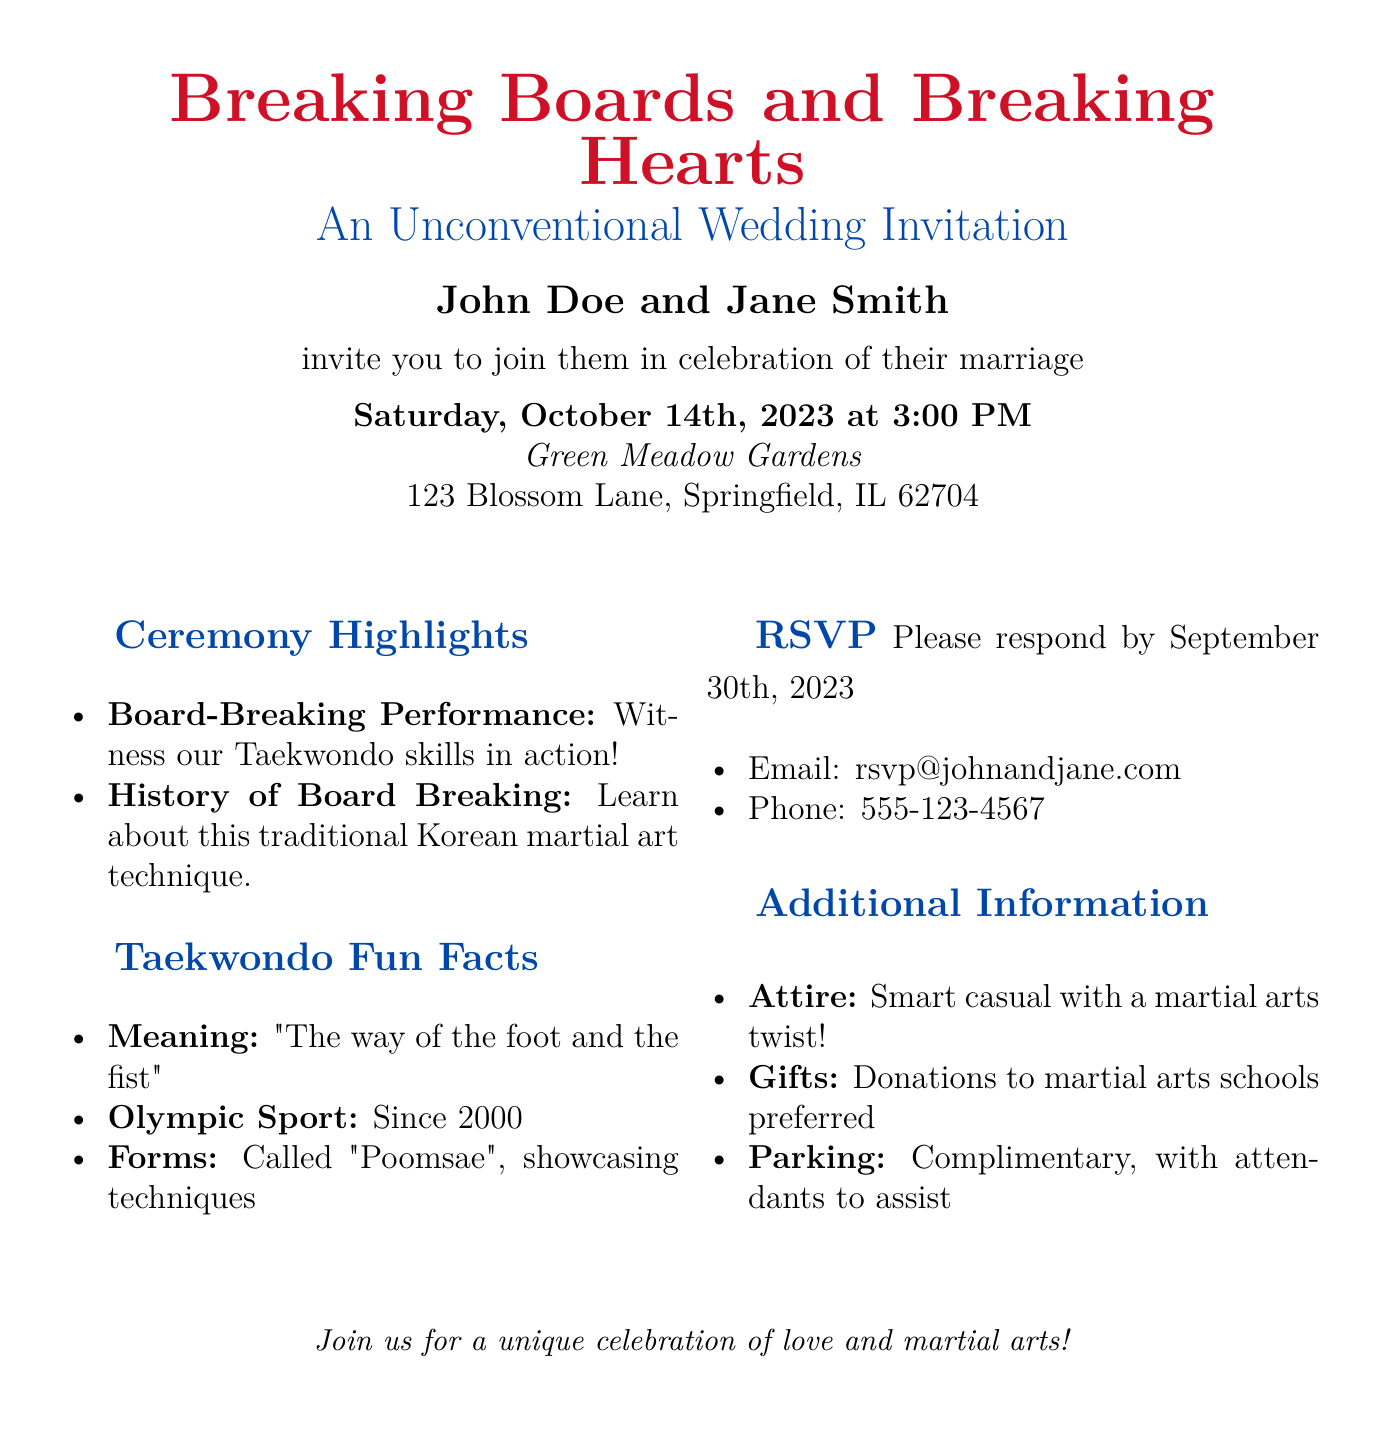What is the couple's names? The document explicitly states the names of the couple inviting guests, which are John Doe and Jane Smith.
Answer: John Doe and Jane Smith What is the wedding date? The invitation specifies the date of the wedding as Saturday, October 14th, 2023.
Answer: Saturday, October 14th, 2023 Where is the ceremony taking place? The location of the wedding ceremony is mentioned in the document as Green Meadow Gardens, along with the address.
Answer: Green Meadow Gardens What unique performance will be featured during the ceremony? The document highlights a board-breaking performance showcasing the couple's Taekwondo skills as part of the ceremony highlights.
Answer: Board-Breaking Performance What is the meaning of Taekwondo mentioned? The document provides a fun fact about the meaning of Taekwondo, which is the "way of the foot and the fist."
Answer: The way of the foot and the fist When is the RSVP deadline? According to the document, the last date to respond for the RSVP is September 30th, 2023.
Answer: September 30th, 2023 What preferred gift option is mentioned? The invitation notes a preference for donations to martial arts schools as gifts.
Answer: Donations to martial arts schools What is suggested attire for the event? The document specifies the suggested attire as smart casual with a martial arts twist.
Answer: Smart casual with a martial arts twist What year was Taekwondo made an Olympic sport? The document states that Taekwondo became an Olympic sport in the year 2000.
Answer: 2000 